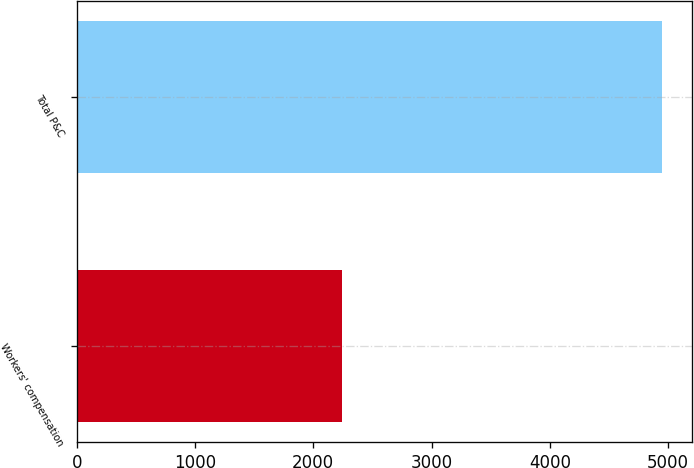Convert chart. <chart><loc_0><loc_0><loc_500><loc_500><bar_chart><fcel>Workers' compensation<fcel>Total P&C<nl><fcel>2242<fcel>4951<nl></chart> 